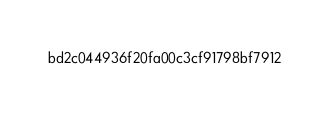<code> <loc_0><loc_0><loc_500><loc_500><_HTML_>bd2c044936f20fa00c3cf91798bf7912</code> 